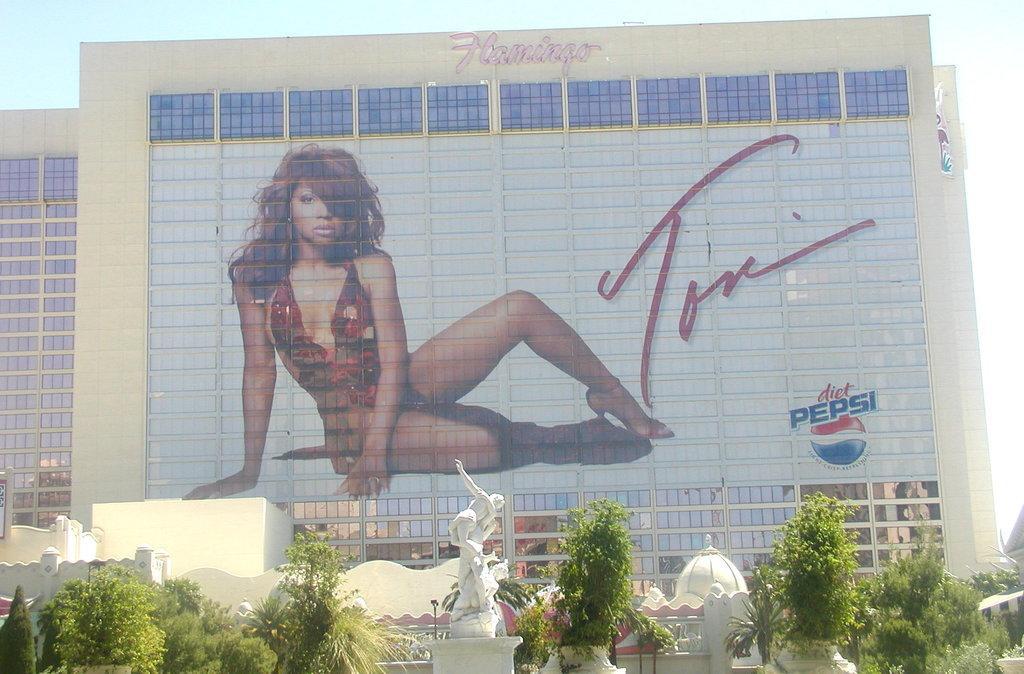Could you give a brief overview of what you see in this image? In this image we can see a girl picture on the wall of a building. In the foreground we can see a statue and a group of trees and in the background we can see the sky. 